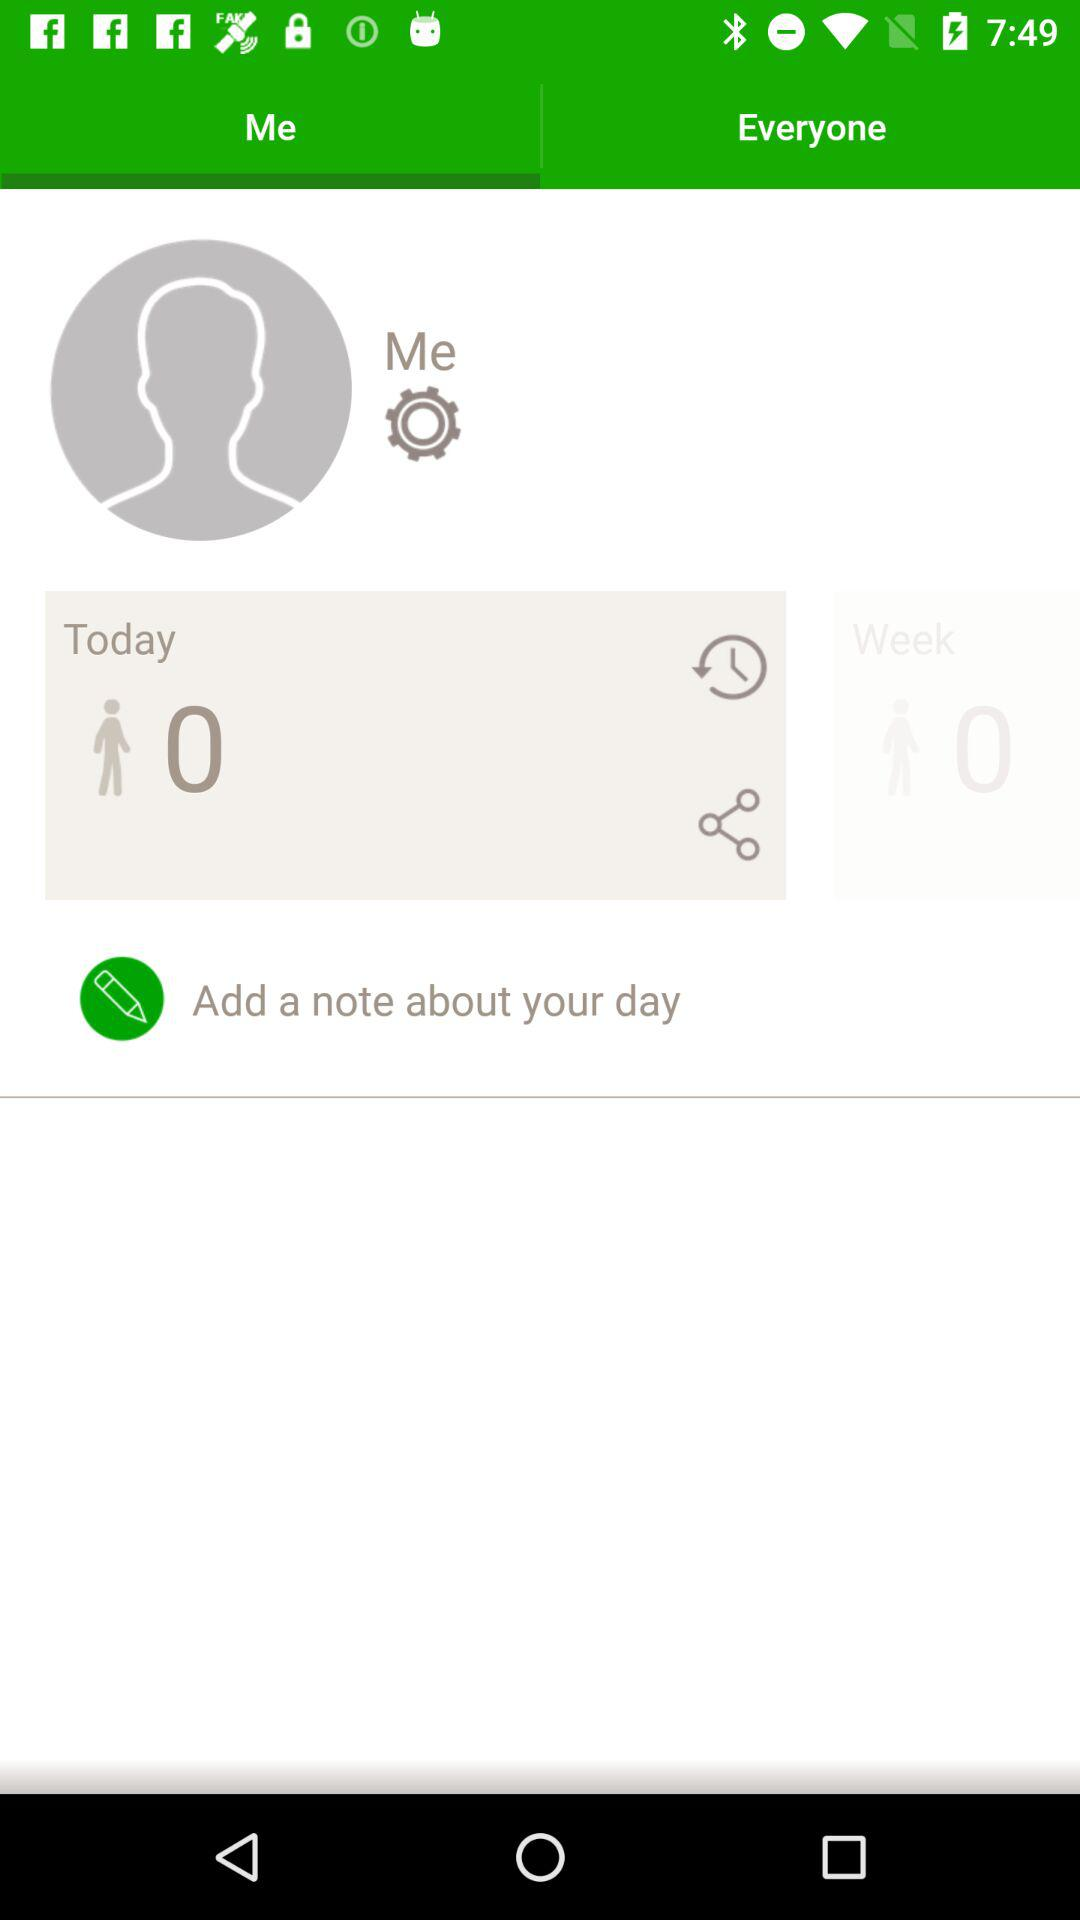Which tab is selected? The selected tab is "Me". 